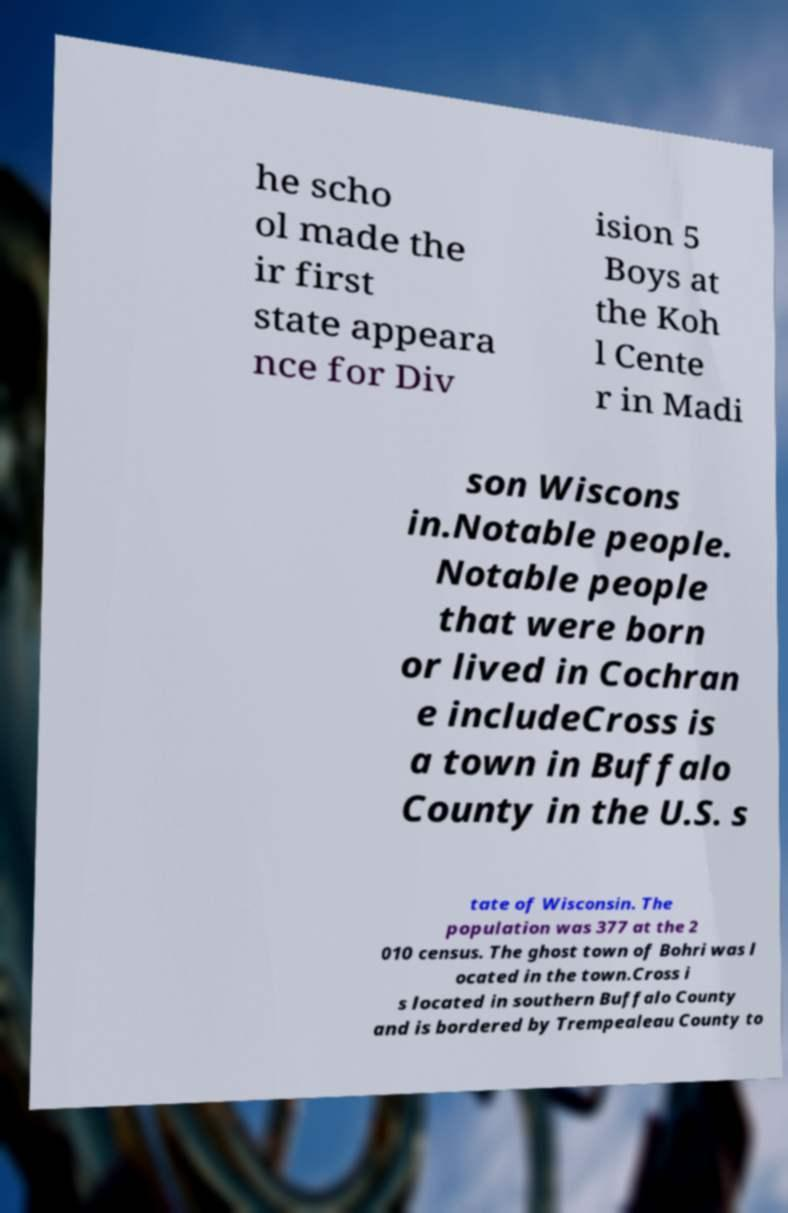For documentation purposes, I need the text within this image transcribed. Could you provide that? he scho ol made the ir first state appeara nce for Div ision 5 Boys at the Koh l Cente r in Madi son Wiscons in.Notable people. Notable people that were born or lived in Cochran e includeCross is a town in Buffalo County in the U.S. s tate of Wisconsin. The population was 377 at the 2 010 census. The ghost town of Bohri was l ocated in the town.Cross i s located in southern Buffalo County and is bordered by Trempealeau County to 